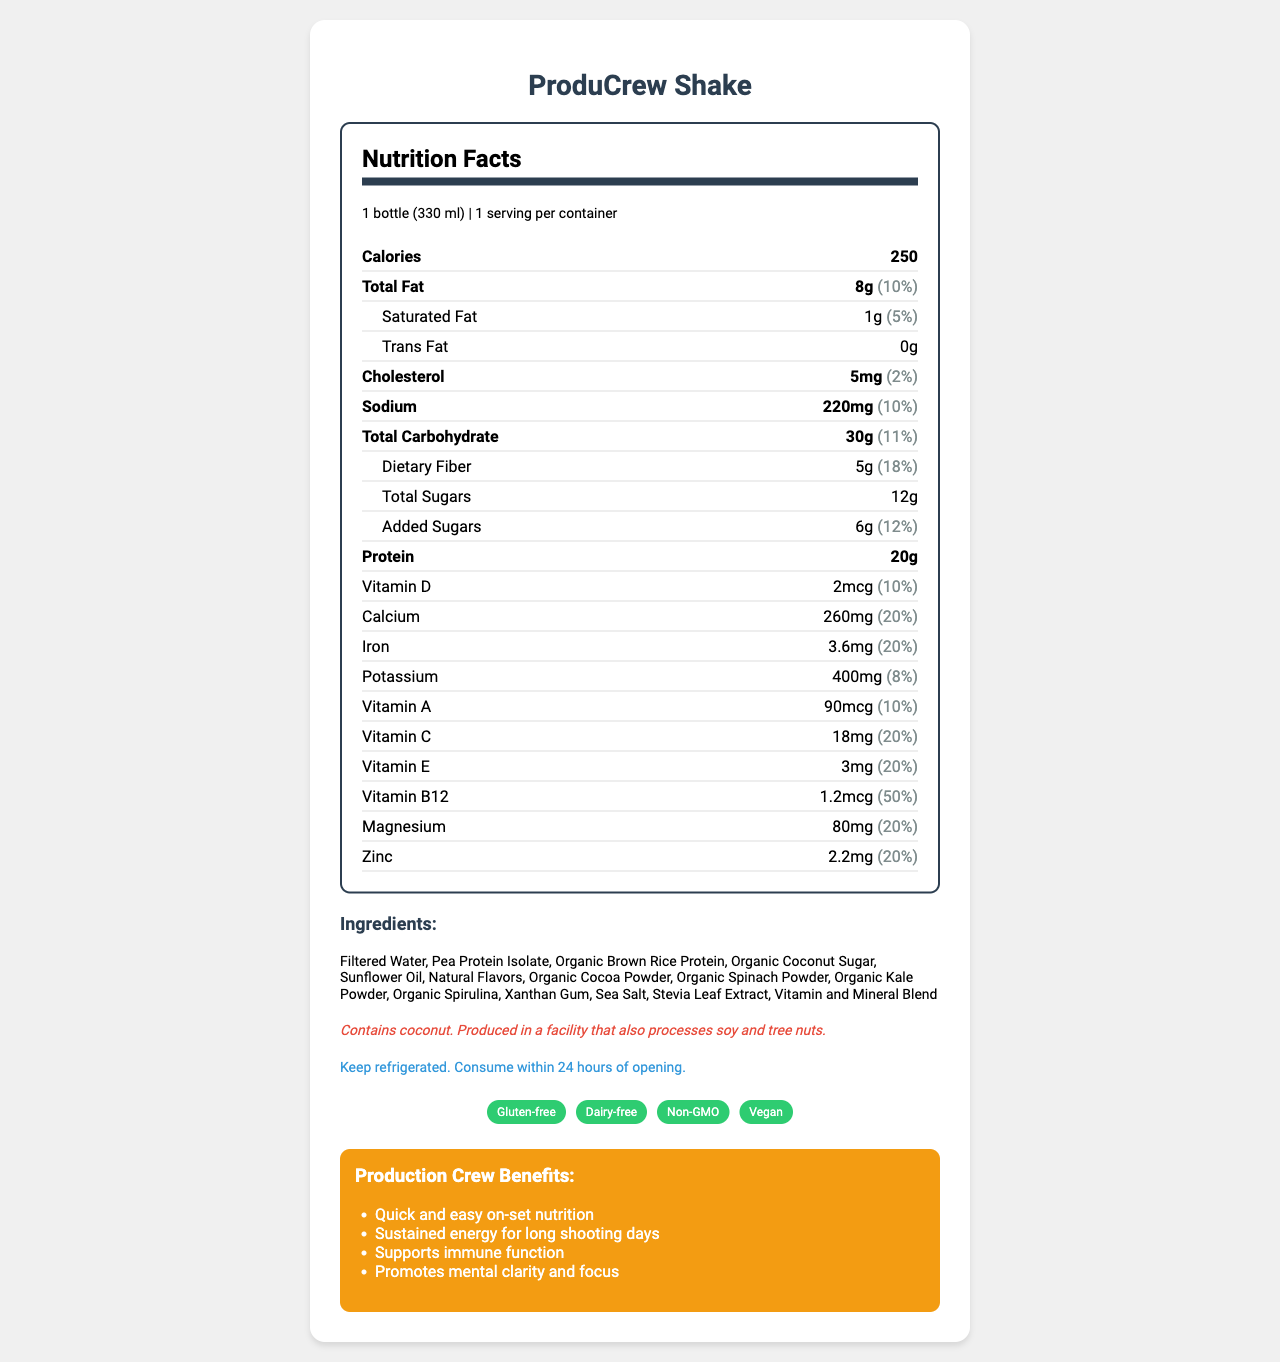What is the serving size of the ProduCrew Shake? The serving size is specified in the document under "serving size" as "1 bottle (330 ml)."
Answer: 1 bottle (330 ml) How many calories are in one serving of ProduCrew Shake? The calories per serving is stated as 250.
Answer: 250 What is the total fat content in ProduCrew Shake? The document lists the total fat content as 8g.
Answer: 8g How much protein does ProduCrew Shake provide per serving? The protein content per serving is given as 20g.
Answer: 20g What percentage of the daily value for vitamin B12 does ProduCrew Shake provide? The document specifies that the shake provides 50% of the daily value for vitamin B12.
Answer: 50% What is the amount of sodium in ProduCrew Shake? A. 150mg B. 200mg C. 220mg D. 250mg The sodium content is listed as 220mg in the document.
Answer: C. 220mg Which of the following ingredients is NOT found in ProduCrew Shake? A. Organic Brown Rice Protein B. Sea Salt C. Almond Milk D. Xanthan Gum The list of ingredients provided does not include Almond Milk.
Answer: C. Almond Milk Is ProduCrew Shake gluten-free? One of the product claims is that it is gluten-free.
Answer: Yes Does ProduCrew Shake contain any allergens? The allergen information states that it contains coconut and is produced in a facility that processes soy and tree nuts.
Answer: Yes What is the main benefit advertised for production crew members? Among the listed benefits, "Quick and easy on-set nutrition" is emphasized as a main benefit.
Answer: Quick and easy on-set nutrition Which vitamins in ProduCrew Shake are listed with a daily value of 20%? The document lists Calcium, Iron, Vitamin C, Vitamin E, Magnesium, and Zinc with each having a daily value of 20%.
Answer: Calcium, Iron, Vitamin C, Vitamin E, Magnesium, Zinc Summarize the key details of the ProduCrew Shake Nutrition Facts label. The summary captures the essential content including nutritional facts, claims, and benefits specific to production crew needs.
Answer: ProduCrew Shake is a healthy meal replacement designed for busy production crew members. It has essential nutrients, including 20g of protein, important vitamins and minerals, and claims to be gluten-free, dairy-free, non-GMO, and vegan. It contains 250 calories per bottle, 8g of total fat, 30g of carbohydrates, and 20g of protein. It also supports immune function, mental clarity, and provides quick on-set nutrition. Based on the nutrition facts, how many grams of trans fat are in the ProduCrew Shake? The document specifically lists the trans fat content as 0g.
Answer: 0g What is the amount of added sugars in ProduCrew Shake? The amount of added sugars is listed as 6g in the document.
Answer: 6g Can we infer the flavor of ProduCrew Shake from the document? The document does not provide any specific information about the flavor of the shake.
Answer: Cannot be determined What are the storage instructions for ProduCrew Shake? The document explicitly states the storage instructions as "Keep refrigerated. Consume within 24 hours of opening."
Answer: Keep refrigerated. Consume within 24 hours of opening. 